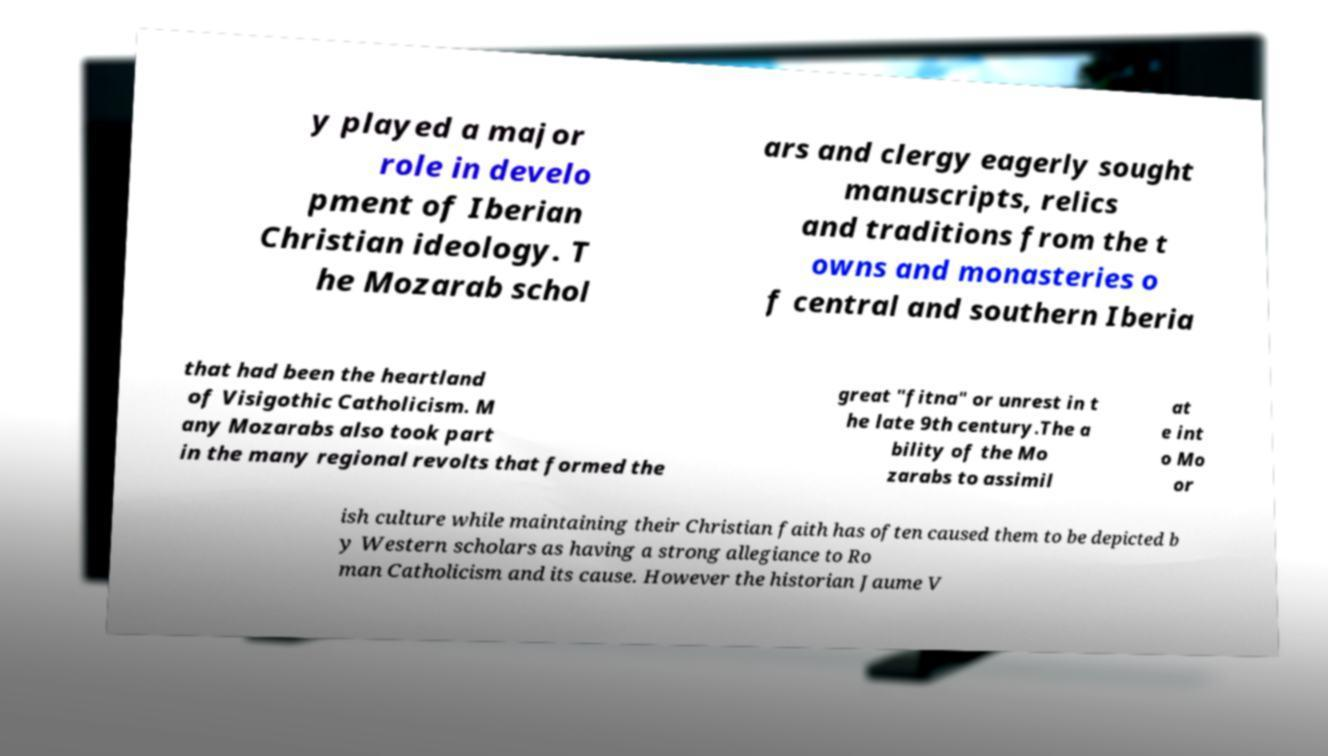For documentation purposes, I need the text within this image transcribed. Could you provide that? y played a major role in develo pment of Iberian Christian ideology. T he Mozarab schol ars and clergy eagerly sought manuscripts, relics and traditions from the t owns and monasteries o f central and southern Iberia that had been the heartland of Visigothic Catholicism. M any Mozarabs also took part in the many regional revolts that formed the great "fitna" or unrest in t he late 9th century.The a bility of the Mo zarabs to assimil at e int o Mo or ish culture while maintaining their Christian faith has often caused them to be depicted b y Western scholars as having a strong allegiance to Ro man Catholicism and its cause. However the historian Jaume V 